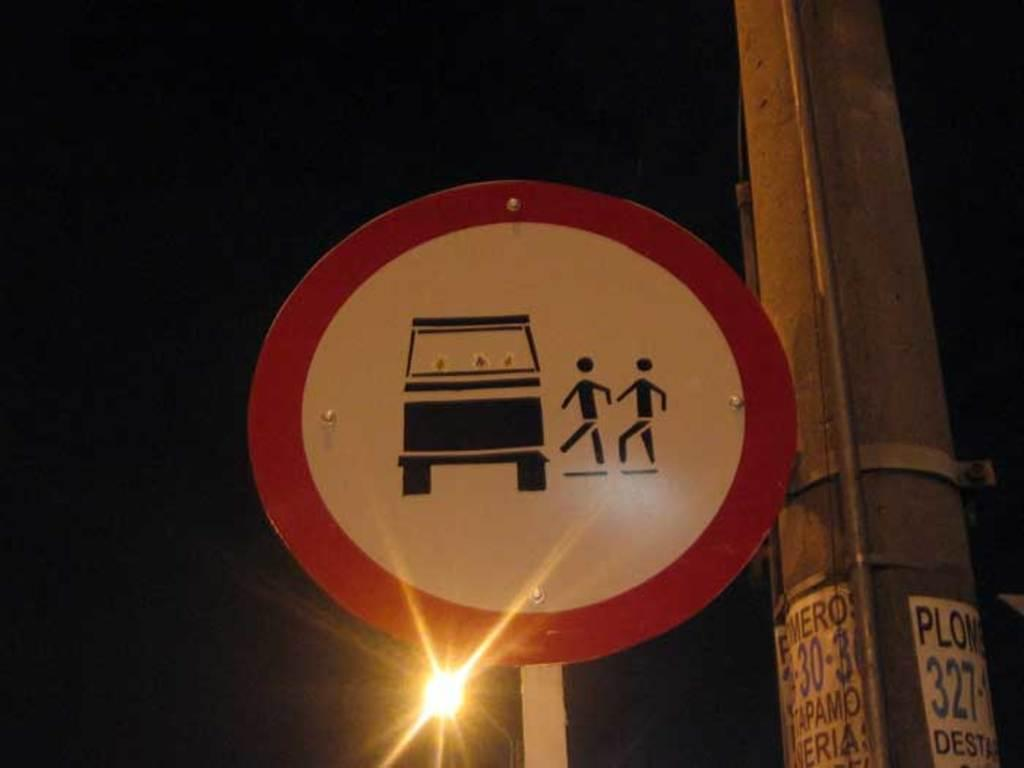What is the main object in the image? There is a pole in the image. What is attached to the pole? There is a label on the pole and a precaution board attached to it. What can be seen in the image besides the pole and its attachments? A light is visible in the image. How would you describe the overall appearance of the image? The backdrop of the image is dark. How many people are jumping around the pole in the image? There are no people visible in the image, let alone jumping around the pole. What type of spade is being used to dig near the pole in the image? There is no spade or digging activity present in the image. 